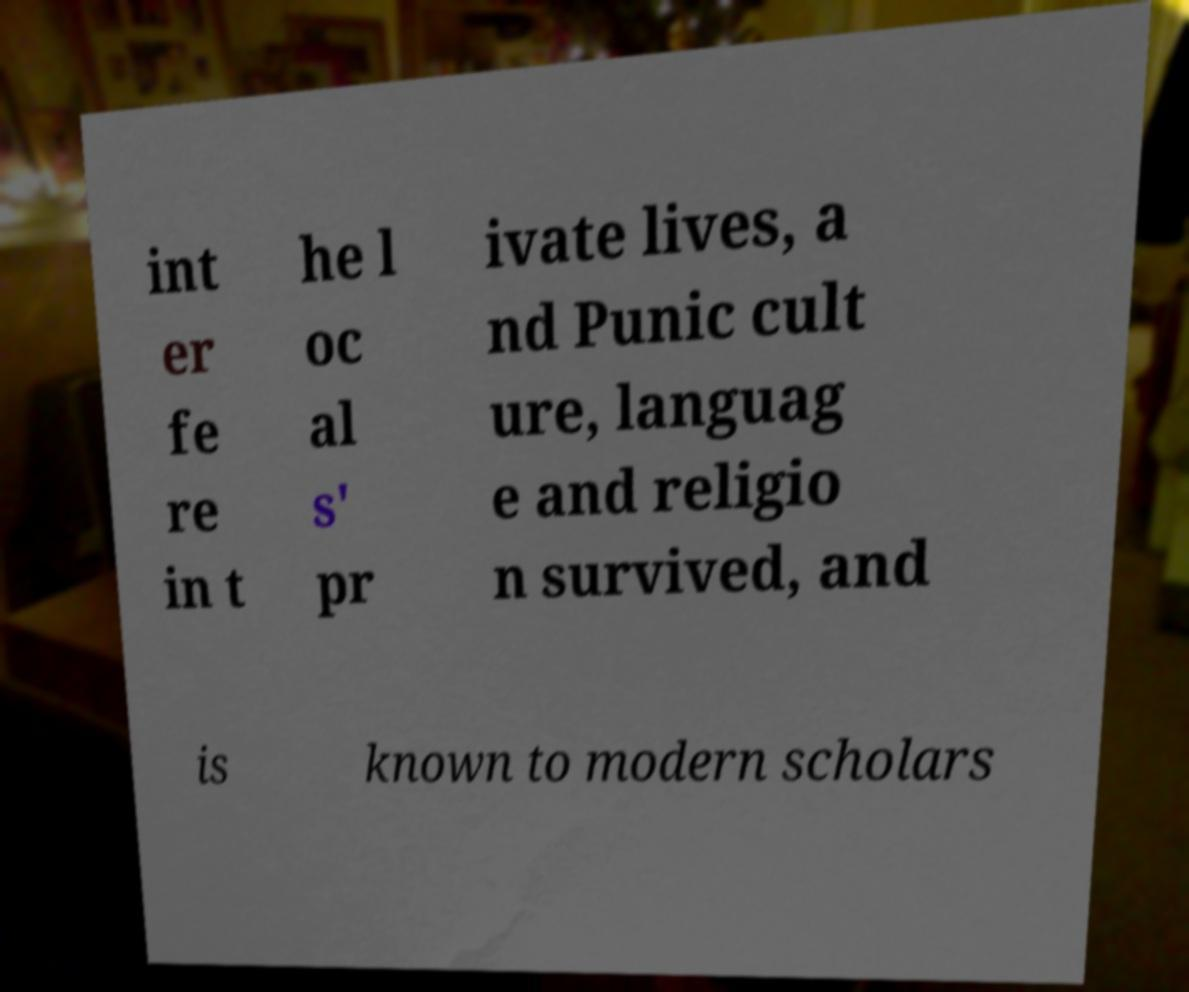I need the written content from this picture converted into text. Can you do that? int er fe re in t he l oc al s' pr ivate lives, a nd Punic cult ure, languag e and religio n survived, and is known to modern scholars 